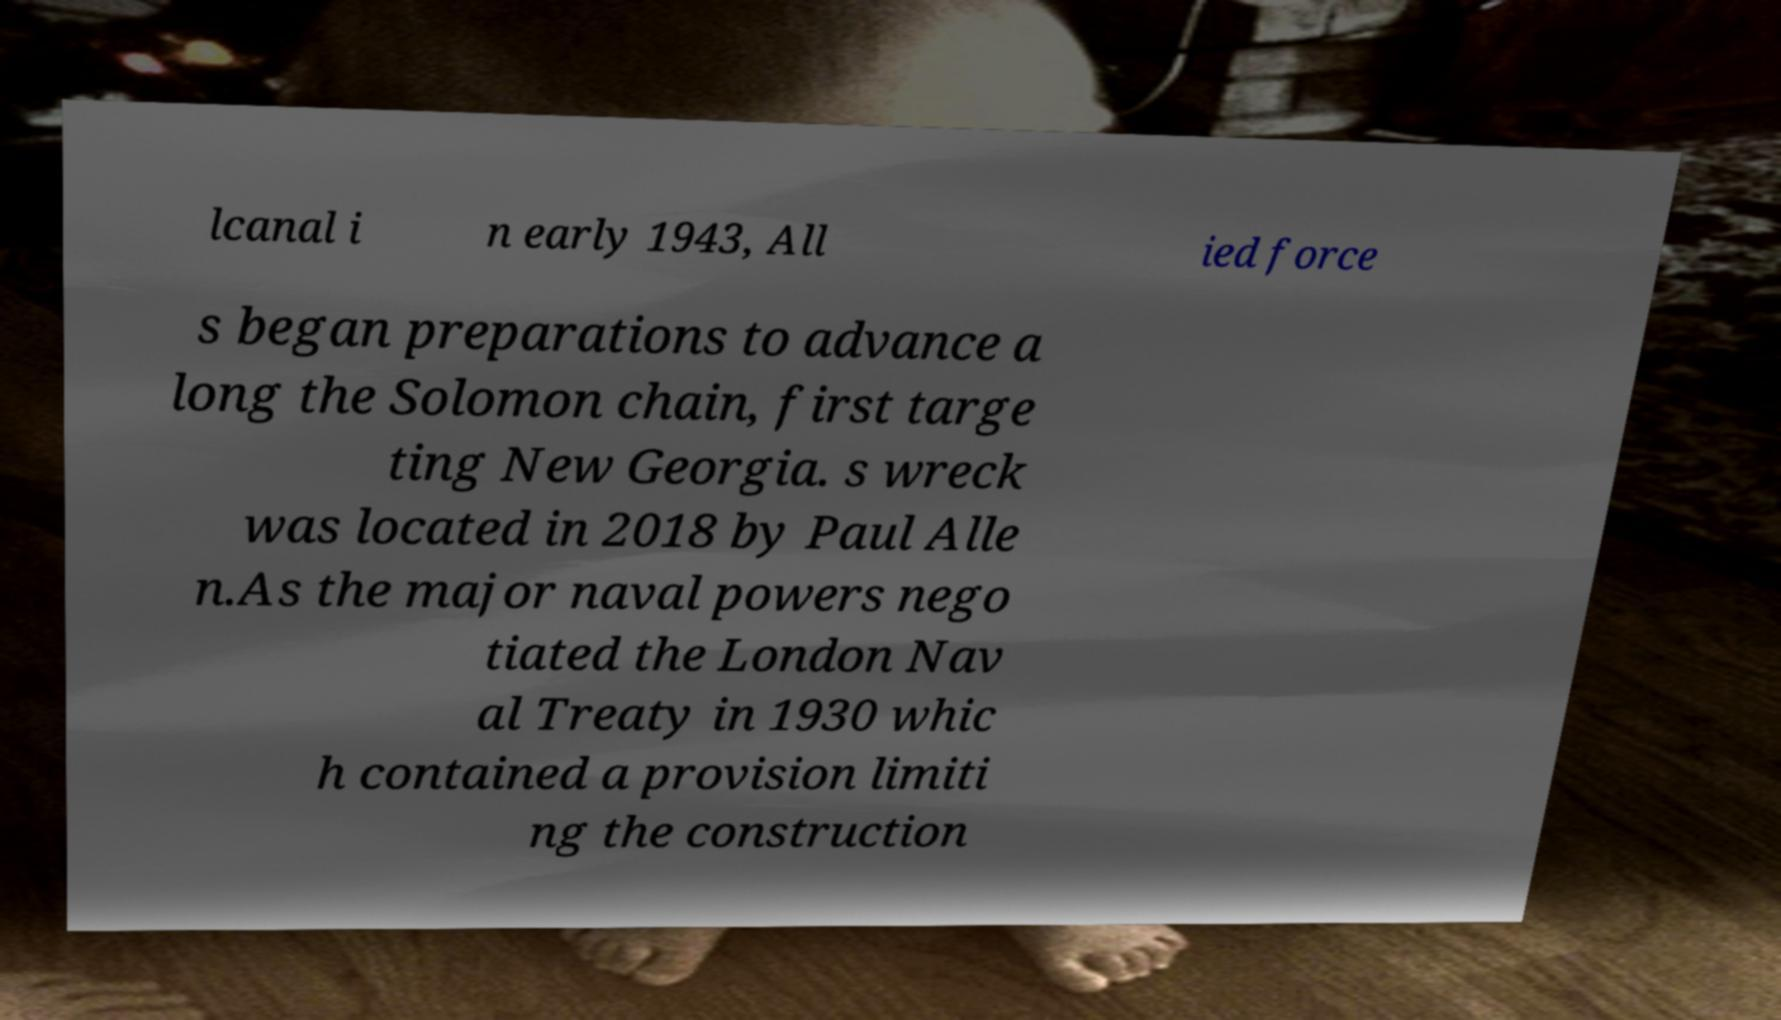Could you extract and type out the text from this image? lcanal i n early 1943, All ied force s began preparations to advance a long the Solomon chain, first targe ting New Georgia. s wreck was located in 2018 by Paul Alle n.As the major naval powers nego tiated the London Nav al Treaty in 1930 whic h contained a provision limiti ng the construction 